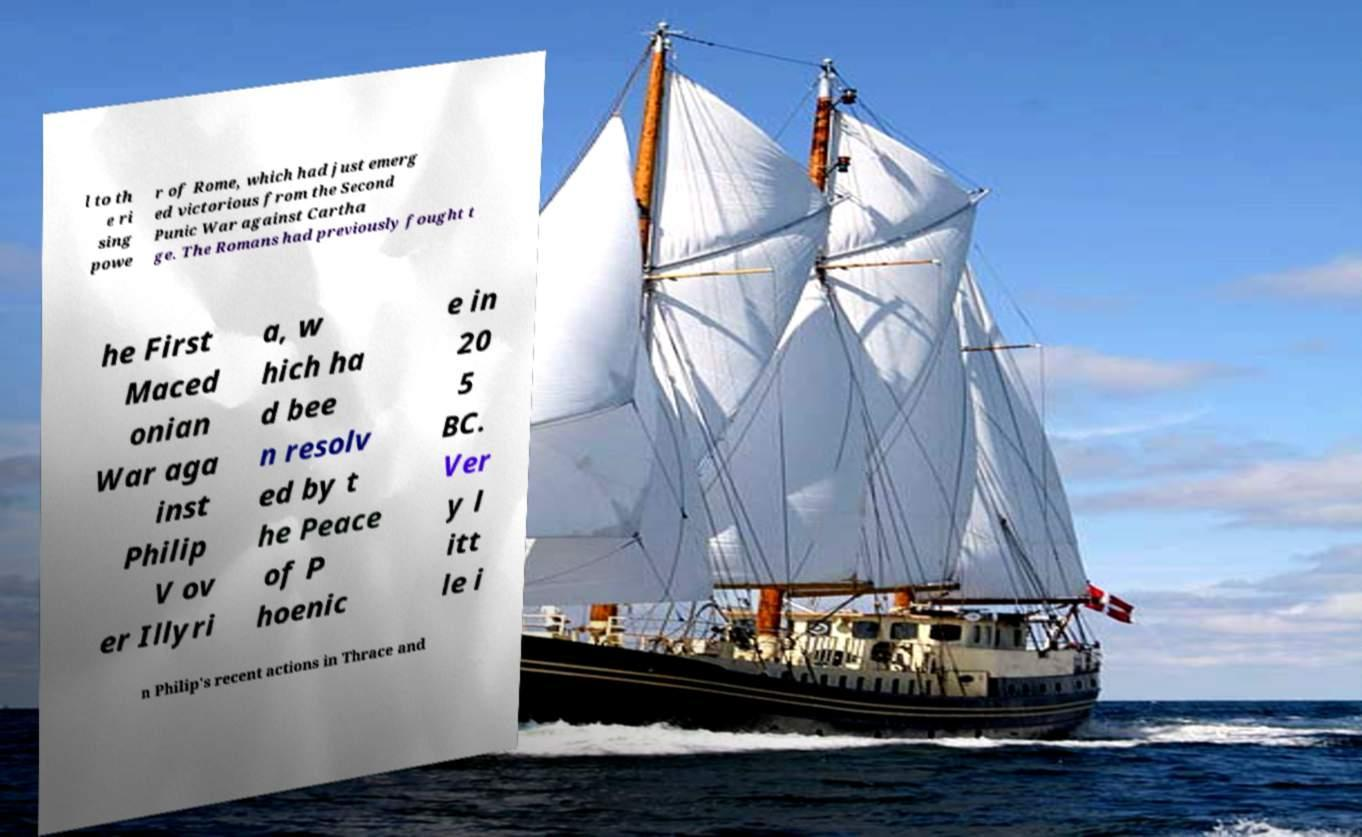Please identify and transcribe the text found in this image. l to th e ri sing powe r of Rome, which had just emerg ed victorious from the Second Punic War against Cartha ge. The Romans had previously fought t he First Maced onian War aga inst Philip V ov er Illyri a, w hich ha d bee n resolv ed by t he Peace of P hoenic e in 20 5 BC. Ver y l itt le i n Philip's recent actions in Thrace and 